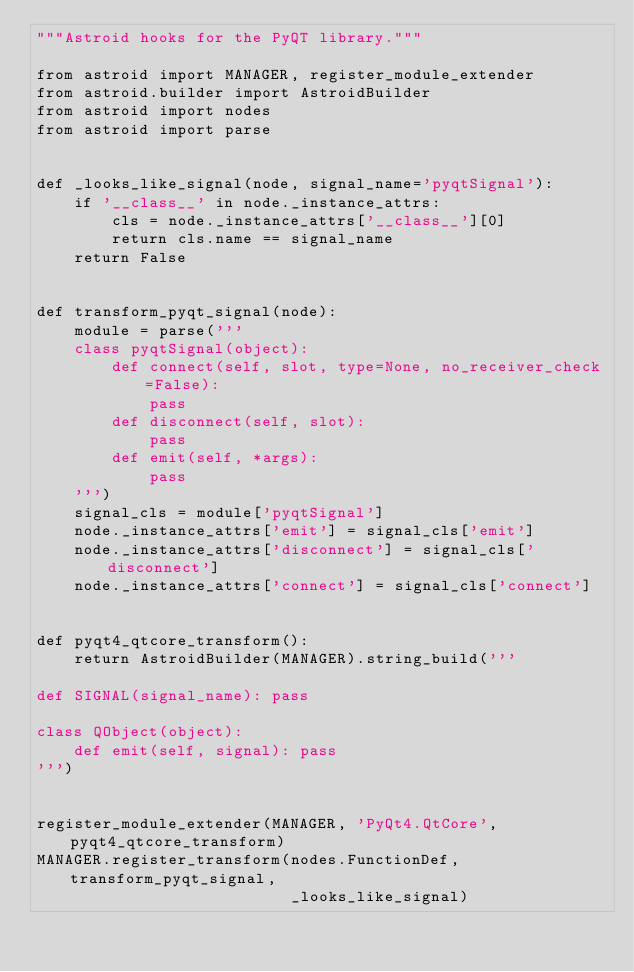<code> <loc_0><loc_0><loc_500><loc_500><_Python_>"""Astroid hooks for the PyQT library."""

from astroid import MANAGER, register_module_extender
from astroid.builder import AstroidBuilder
from astroid import nodes
from astroid import parse


def _looks_like_signal(node, signal_name='pyqtSignal'):
    if '__class__' in node._instance_attrs:
        cls = node._instance_attrs['__class__'][0]
        return cls.name == signal_name
    return False


def transform_pyqt_signal(node):    
    module = parse('''
    class pyqtSignal(object):
        def connect(self, slot, type=None, no_receiver_check=False):
            pass
        def disconnect(self, slot):
            pass
        def emit(self, *args):
            pass
    ''')
    signal_cls = module['pyqtSignal']
    node._instance_attrs['emit'] = signal_cls['emit']
    node._instance_attrs['disconnect'] = signal_cls['disconnect']
    node._instance_attrs['connect'] = signal_cls['connect']


def pyqt4_qtcore_transform():
    return AstroidBuilder(MANAGER).string_build('''

def SIGNAL(signal_name): pass

class QObject(object):
    def emit(self, signal): pass
''')


register_module_extender(MANAGER, 'PyQt4.QtCore', pyqt4_qtcore_transform)
MANAGER.register_transform(nodes.FunctionDef, transform_pyqt_signal,
                           _looks_like_signal)</code> 